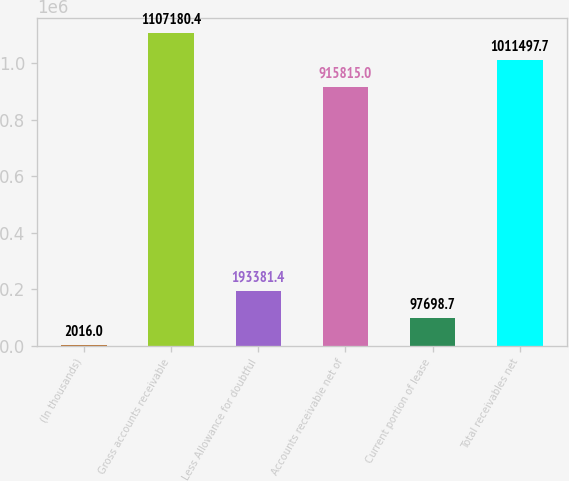<chart> <loc_0><loc_0><loc_500><loc_500><bar_chart><fcel>(In thousands)<fcel>Gross accounts receivable<fcel>Less Allowance for doubtful<fcel>Accounts receivable net of<fcel>Current portion of lease<fcel>Total receivables net<nl><fcel>2016<fcel>1.10718e+06<fcel>193381<fcel>915815<fcel>97698.7<fcel>1.0115e+06<nl></chart> 